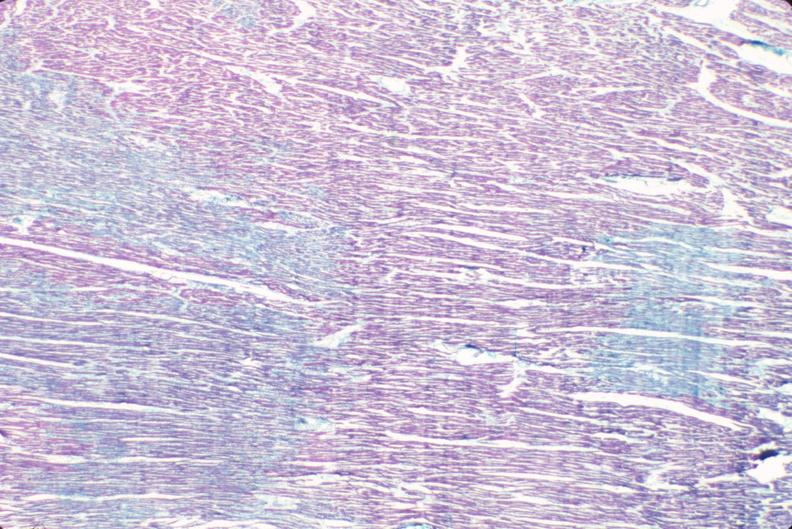does this image show heart, acute myocardial infarction?
Answer the question using a single word or phrase. Yes 